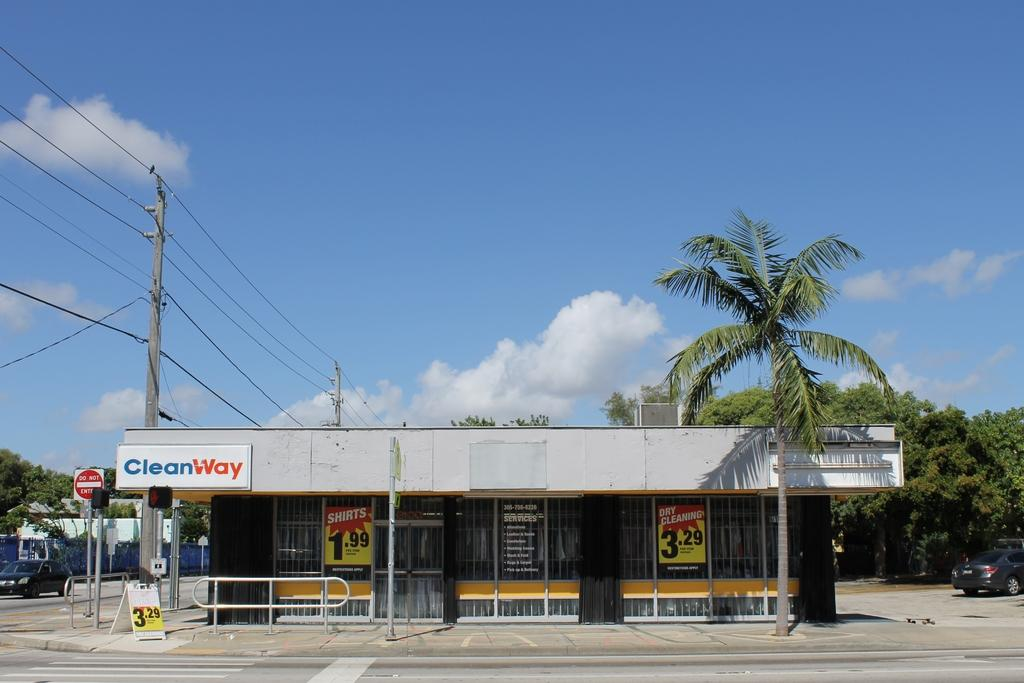Where was the image taken? The image was taken outside. What is the main subject in the middle of the image? There is a store in the middle of the image. What type of vegetation is on the right side of the image? There are trees on the right side of the image. What can be seen on the left side of the image? There is a car on the left side of the image. What is visible at the top of the image? The sky is visible at the top of the image. What type of love can be seen between the trees in the image? There is no love present between the trees in the image; they are inanimate objects. 